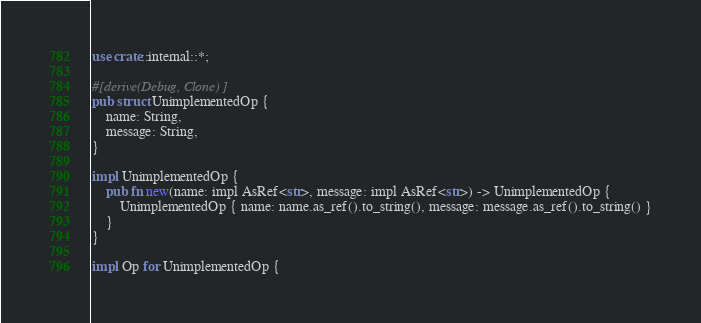Convert code to text. <code><loc_0><loc_0><loc_500><loc_500><_Rust_>use crate::internal::*;

#[derive(Debug, Clone)]
pub struct UnimplementedOp {
    name: String,
    message: String,
}

impl UnimplementedOp {
    pub fn new(name: impl AsRef<str>, message: impl AsRef<str>) -> UnimplementedOp {
        UnimplementedOp { name: name.as_ref().to_string(), message: message.as_ref().to_string() }
    }
}

impl Op for UnimplementedOp {</code> 